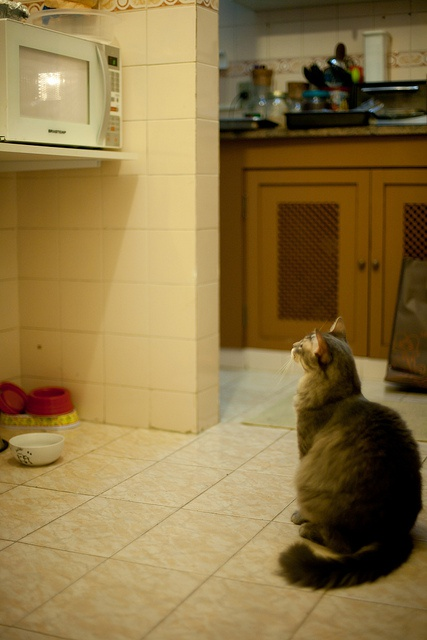Describe the objects in this image and their specific colors. I can see cat in khaki, black, and olive tones, microwave in khaki and tan tones, bowl in khaki, tan, and olive tones, and bowl in khaki and maroon tones in this image. 